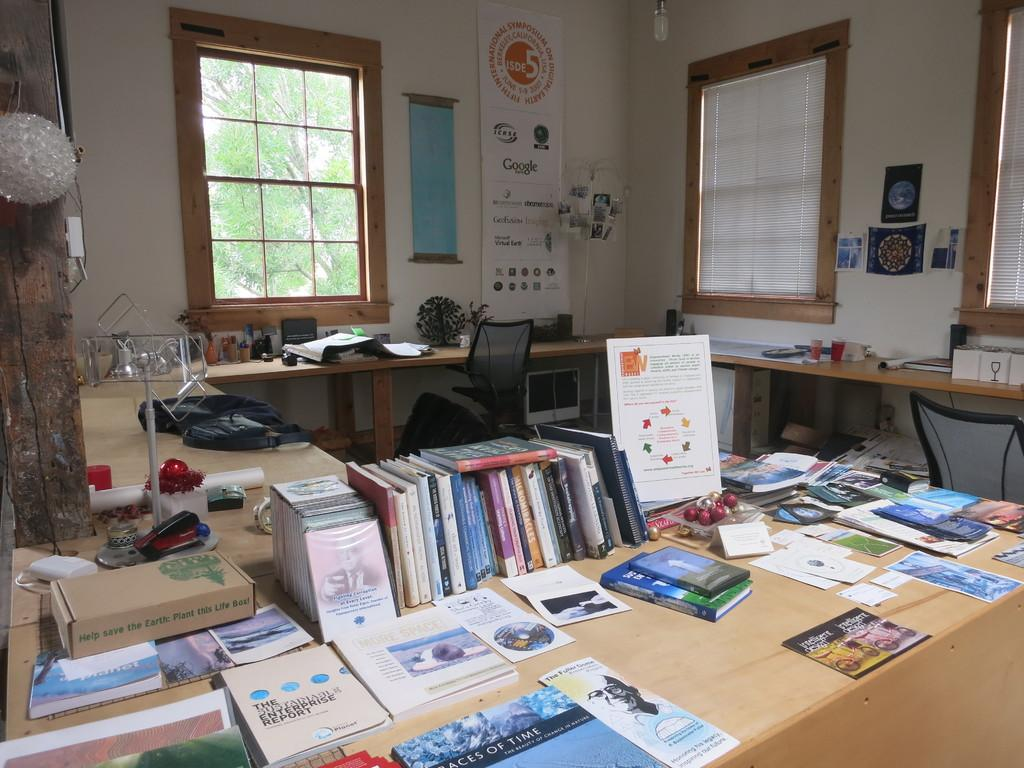What type of furniture is present in the image? There is a table in the image. What items can be seen on the table? There are books on the table. What architectural feature is visible in the image? There is a window in the image. What type of surface is visible in the image? There is a wall in the image. What type of decorations are present in the image? There are posters in the image. Can you see any lettuce growing in the image? There is no lettuce visible in the image. How many legs does the table have in the image? The image does not show the legs of the table, so it is impossible to determine the number of legs. 